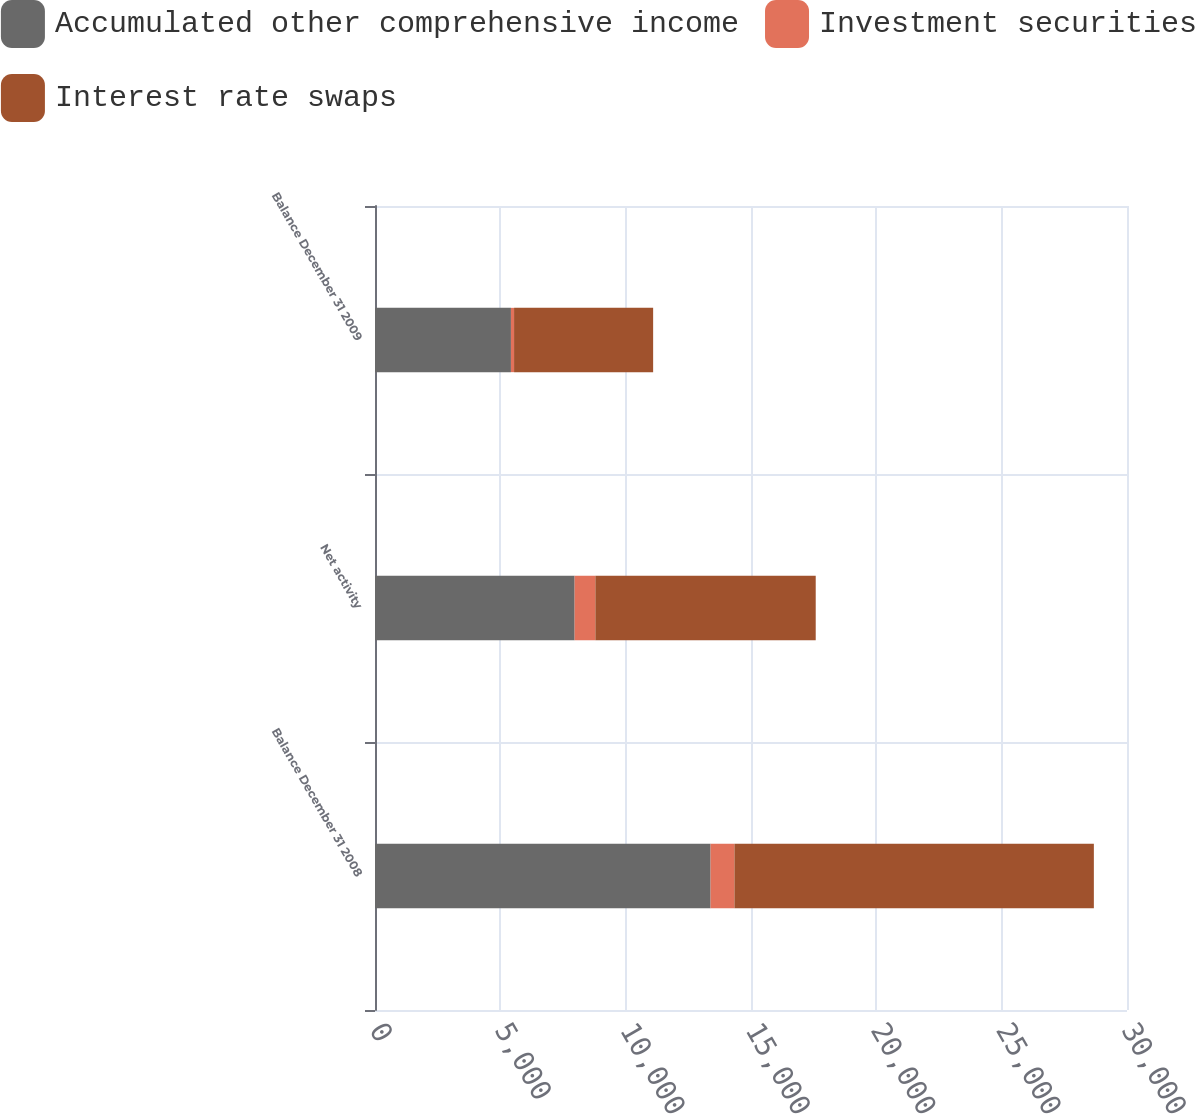Convert chart to OTSL. <chart><loc_0><loc_0><loc_500><loc_500><stacked_bar_chart><ecel><fcel>Balance December 31 2008<fcel>Net activity<fcel>Balance December 31 2009<nl><fcel>Accumulated other comprehensive income<fcel>13387<fcel>7964<fcel>5423<nl><fcel>Investment securities<fcel>952<fcel>827<fcel>125<nl><fcel>Interest rate swaps<fcel>14339<fcel>8791<fcel>5548<nl></chart> 